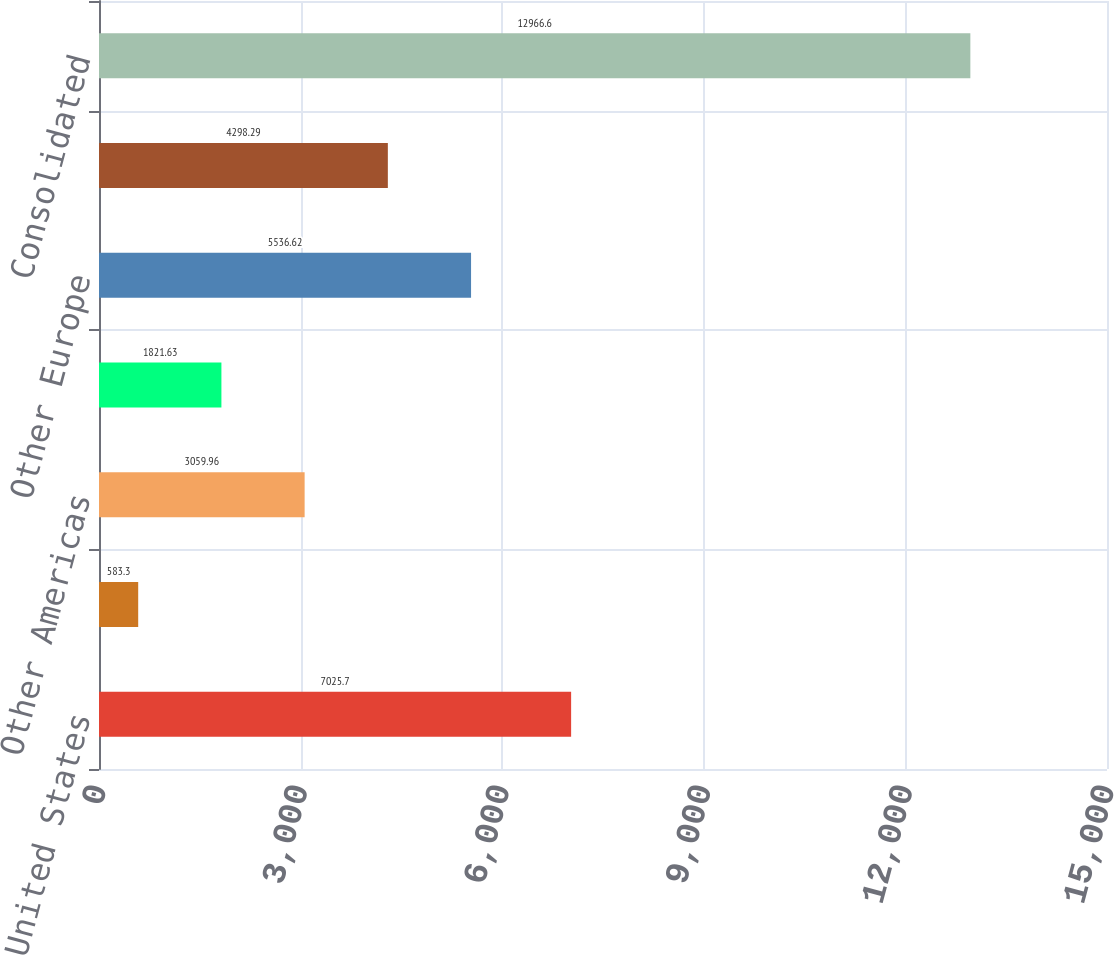<chart> <loc_0><loc_0><loc_500><loc_500><bar_chart><fcel>United States<fcel>Canada<fcel>Other Americas<fcel>France<fcel>Other Europe<fcel>Asia<fcel>Consolidated<nl><fcel>7025.7<fcel>583.3<fcel>3059.96<fcel>1821.63<fcel>5536.62<fcel>4298.29<fcel>12966.6<nl></chart> 